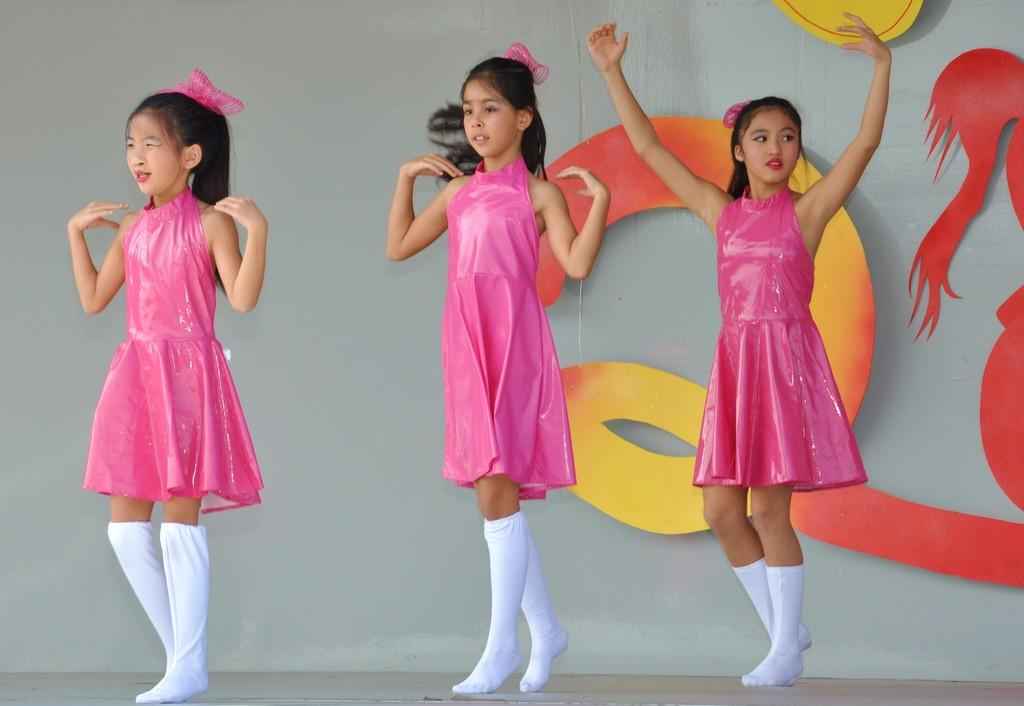What is the main subject of the image? The main subject of the image is the girls. What are the girls doing in the image? The girls appear to be dancing. What can be seen in the background of the image? There is a painting in the background of the image. How many birds can be seen joining the girls in the image? There are no birds present in the image, so it is not possible to determine how many might be joining the girls. 